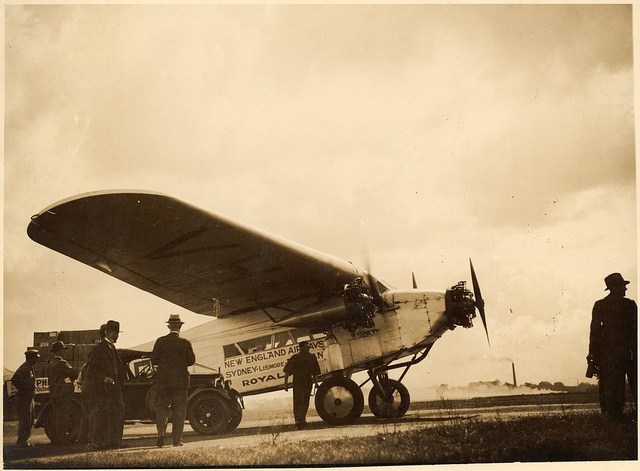Describe the objects in this image and their specific colors. I can see airplane in beige, black, tan, and maroon tones, truck in beige, black, maroon, and tan tones, people in beige, black, and gray tones, people in beige, black, maroon, and tan tones, and people in beige, black, maroon, and gray tones in this image. 